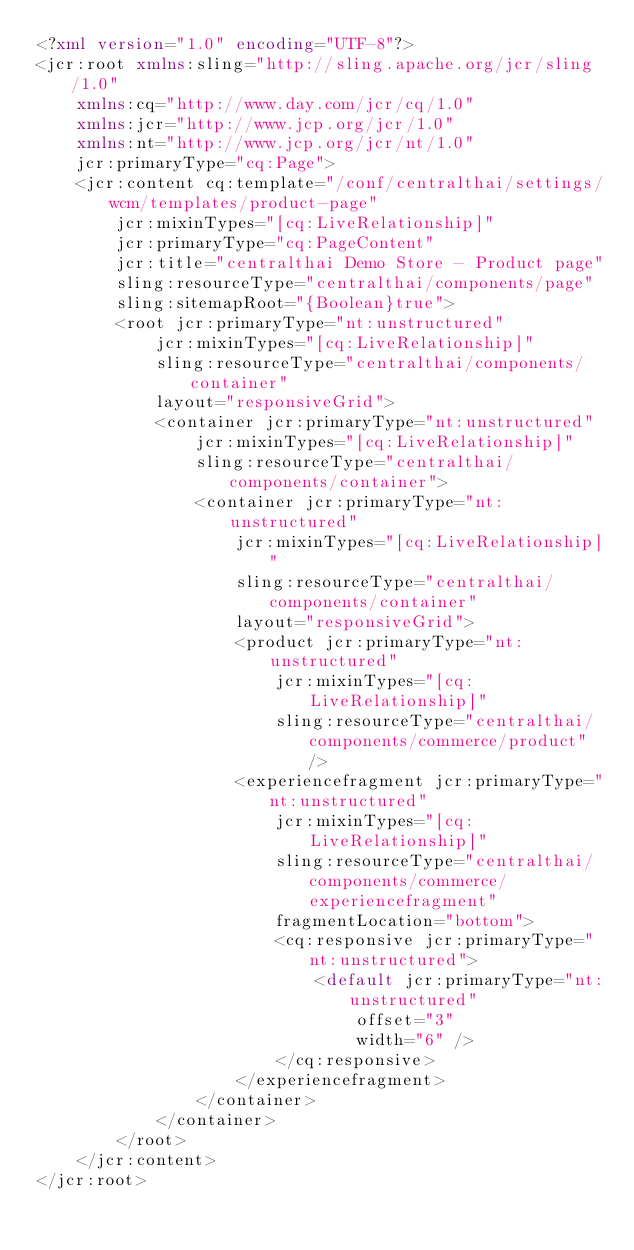Convert code to text. <code><loc_0><loc_0><loc_500><loc_500><_XML_><?xml version="1.0" encoding="UTF-8"?>
<jcr:root xmlns:sling="http://sling.apache.org/jcr/sling/1.0" 
    xmlns:cq="http://www.day.com/jcr/cq/1.0" 
    xmlns:jcr="http://www.jcp.org/jcr/1.0" 
    xmlns:nt="http://www.jcp.org/jcr/nt/1.0" 
    jcr:primaryType="cq:Page">
    <jcr:content cq:template="/conf/centralthai/settings/wcm/templates/product-page" 
        jcr:mixinTypes="[cq:LiveRelationship]" 
        jcr:primaryType="cq:PageContent" 
        jcr:title="centralthai Demo Store - Product page"
        sling:resourceType="centralthai/components/page"
        sling:sitemapRoot="{Boolean}true">
        <root jcr:primaryType="nt:unstructured"
            jcr:mixinTypes="[cq:LiveRelationship]"  
            sling:resourceType="centralthai/components/container" 
            layout="responsiveGrid">
            <container jcr:primaryType="nt:unstructured"
                jcr:mixinTypes="[cq:LiveRelationship]" 
                sling:resourceType="centralthai/components/container">
                <container jcr:primaryType="nt:unstructured"
                    jcr:mixinTypes="[cq:LiveRelationship]" 
                    sling:resourceType="centralthai/components/container" 
                    layout="responsiveGrid">
                    <product jcr:primaryType="nt:unstructured"
                        jcr:mixinTypes="[cq:LiveRelationship]"
                        sling:resourceType="centralthai/components/commerce/product" />
                    <experiencefragment jcr:primaryType="nt:unstructured"
                        jcr:mixinTypes="[cq:LiveRelationship]"
                        sling:resourceType="centralthai/components/commerce/experiencefragment"
                        fragmentLocation="bottom">
                        <cq:responsive jcr:primaryType="nt:unstructured">
                            <default jcr:primaryType="nt:unstructured"
                                offset="3"
                                width="6" />
                        </cq:responsive>
                    </experiencefragment>
                </container>
            </container>
        </root>
    </jcr:content>
</jcr:root></code> 